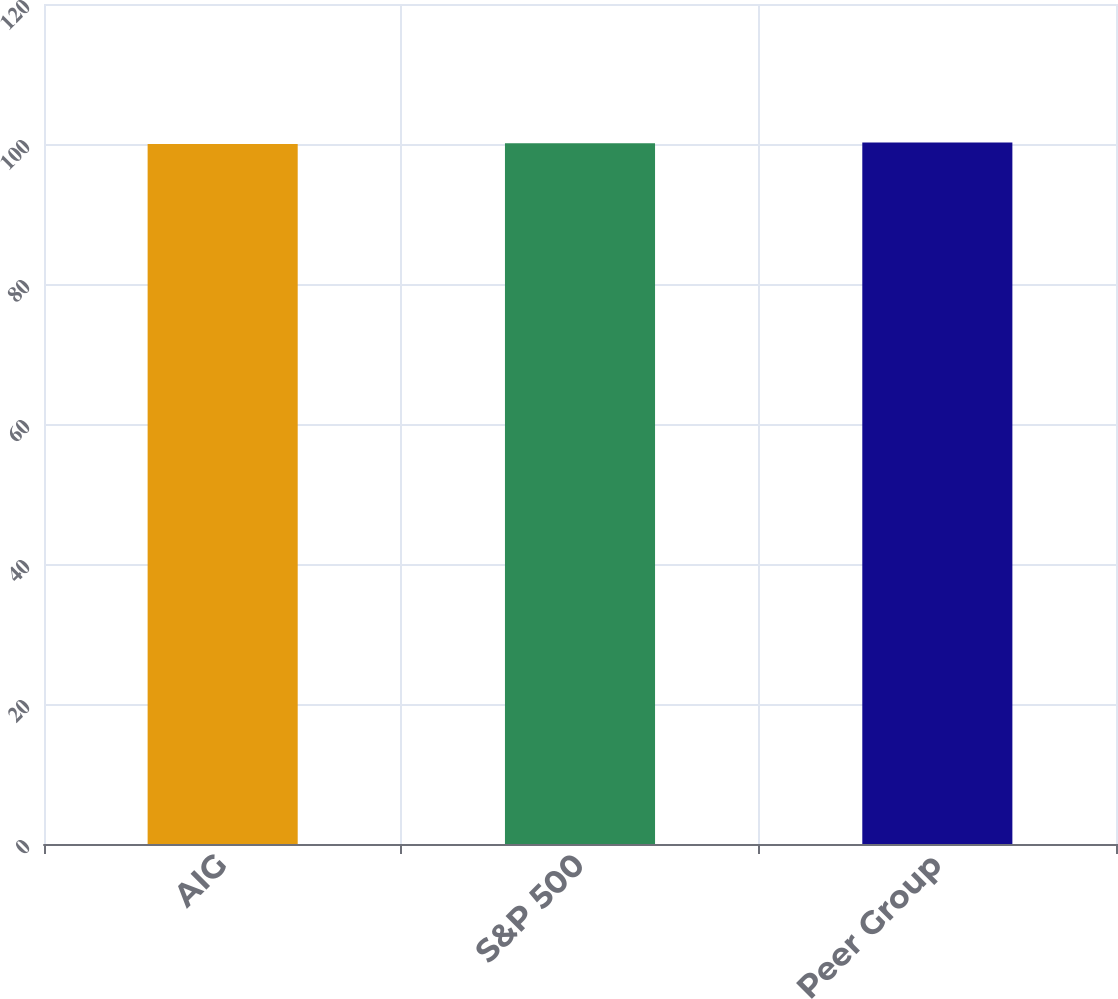<chart> <loc_0><loc_0><loc_500><loc_500><bar_chart><fcel>AIG<fcel>S&P 500<fcel>Peer Group<nl><fcel>100<fcel>100.1<fcel>100.2<nl></chart> 